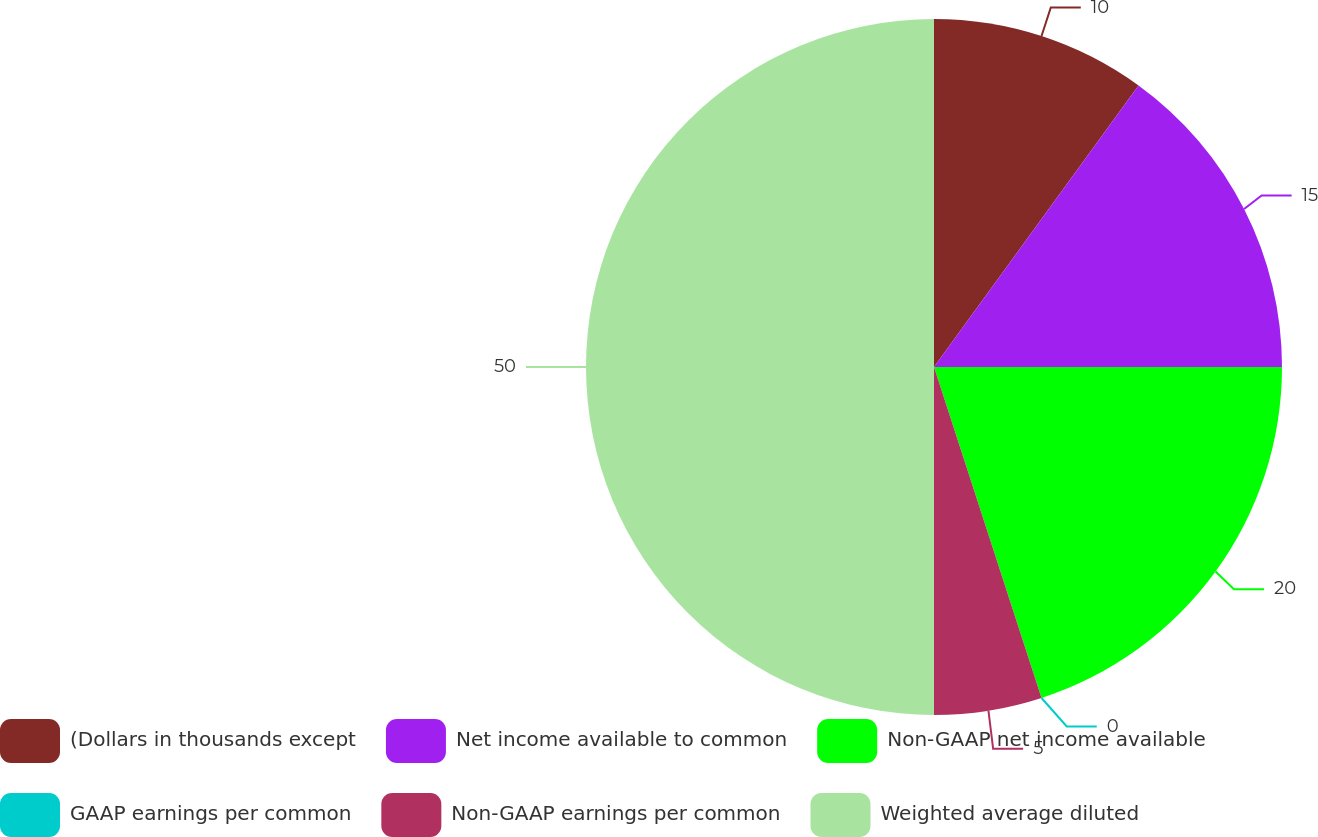Convert chart. <chart><loc_0><loc_0><loc_500><loc_500><pie_chart><fcel>(Dollars in thousands except<fcel>Net income available to common<fcel>Non-GAAP net income available<fcel>GAAP earnings per common<fcel>Non-GAAP earnings per common<fcel>Weighted average diluted<nl><fcel>10.0%<fcel>15.0%<fcel>20.0%<fcel>0.0%<fcel>5.0%<fcel>50.0%<nl></chart> 